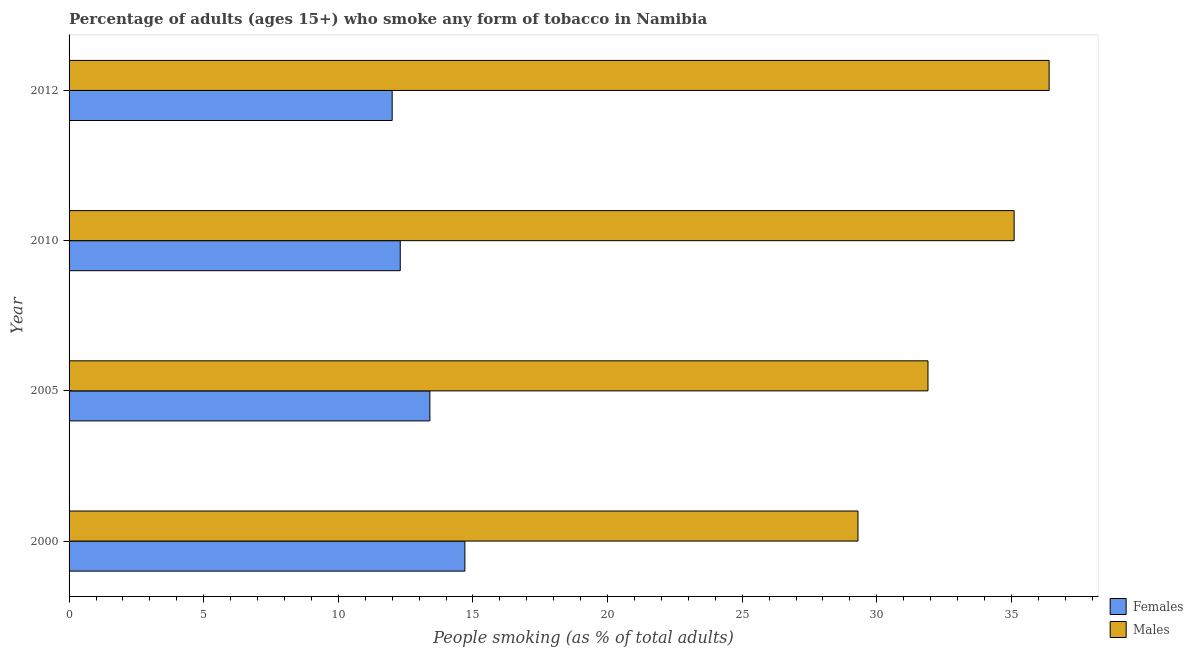Are the number of bars per tick equal to the number of legend labels?
Ensure brevity in your answer.  Yes. Are the number of bars on each tick of the Y-axis equal?
Give a very brief answer. Yes. In how many cases, is the number of bars for a given year not equal to the number of legend labels?
Offer a very short reply. 0. What is the percentage of males who smoke in 2000?
Your response must be concise. 29.3. Across all years, what is the maximum percentage of males who smoke?
Offer a terse response. 36.4. Across all years, what is the minimum percentage of males who smoke?
Your response must be concise. 29.3. In which year was the percentage of females who smoke maximum?
Provide a short and direct response. 2000. In which year was the percentage of males who smoke minimum?
Make the answer very short. 2000. What is the total percentage of females who smoke in the graph?
Your response must be concise. 52.4. What is the difference between the percentage of males who smoke in 2000 and the percentage of females who smoke in 2010?
Provide a short and direct response. 17. What is the average percentage of males who smoke per year?
Offer a very short reply. 33.17. In the year 2010, what is the difference between the percentage of females who smoke and percentage of males who smoke?
Provide a succinct answer. -22.8. In how many years, is the percentage of males who smoke greater than 25 %?
Make the answer very short. 4. What is the ratio of the percentage of females who smoke in 2005 to that in 2010?
Your answer should be compact. 1.09. Is the percentage of males who smoke in 2000 less than that in 2012?
Keep it short and to the point. Yes. What is the difference between the highest and the second highest percentage of males who smoke?
Your response must be concise. 1.3. What is the difference between the highest and the lowest percentage of males who smoke?
Your answer should be very brief. 7.1. In how many years, is the percentage of males who smoke greater than the average percentage of males who smoke taken over all years?
Offer a terse response. 2. What does the 2nd bar from the top in 2000 represents?
Your response must be concise. Females. What does the 2nd bar from the bottom in 2000 represents?
Offer a very short reply. Males. How many bars are there?
Your answer should be very brief. 8. How many years are there in the graph?
Your answer should be very brief. 4. What is the difference between two consecutive major ticks on the X-axis?
Keep it short and to the point. 5. Are the values on the major ticks of X-axis written in scientific E-notation?
Your answer should be compact. No. Does the graph contain any zero values?
Your answer should be very brief. No. Does the graph contain grids?
Give a very brief answer. No. Where does the legend appear in the graph?
Keep it short and to the point. Bottom right. What is the title of the graph?
Offer a terse response. Percentage of adults (ages 15+) who smoke any form of tobacco in Namibia. What is the label or title of the X-axis?
Provide a succinct answer. People smoking (as % of total adults). What is the People smoking (as % of total adults) in Females in 2000?
Make the answer very short. 14.7. What is the People smoking (as % of total adults) in Males in 2000?
Give a very brief answer. 29.3. What is the People smoking (as % of total adults) of Males in 2005?
Offer a very short reply. 31.9. What is the People smoking (as % of total adults) in Males in 2010?
Provide a succinct answer. 35.1. What is the People smoking (as % of total adults) of Females in 2012?
Your response must be concise. 12. What is the People smoking (as % of total adults) in Males in 2012?
Your answer should be very brief. 36.4. Across all years, what is the maximum People smoking (as % of total adults) in Females?
Provide a succinct answer. 14.7. Across all years, what is the maximum People smoking (as % of total adults) in Males?
Your response must be concise. 36.4. Across all years, what is the minimum People smoking (as % of total adults) of Females?
Keep it short and to the point. 12. Across all years, what is the minimum People smoking (as % of total adults) of Males?
Your answer should be compact. 29.3. What is the total People smoking (as % of total adults) in Females in the graph?
Make the answer very short. 52.4. What is the total People smoking (as % of total adults) in Males in the graph?
Make the answer very short. 132.7. What is the difference between the People smoking (as % of total adults) of Females in 2000 and that in 2005?
Keep it short and to the point. 1.3. What is the difference between the People smoking (as % of total adults) in Males in 2000 and that in 2005?
Keep it short and to the point. -2.6. What is the difference between the People smoking (as % of total adults) of Males in 2000 and that in 2010?
Your answer should be compact. -5.8. What is the difference between the People smoking (as % of total adults) in Females in 2005 and that in 2012?
Make the answer very short. 1.4. What is the difference between the People smoking (as % of total adults) in Females in 2000 and the People smoking (as % of total adults) in Males in 2005?
Keep it short and to the point. -17.2. What is the difference between the People smoking (as % of total adults) of Females in 2000 and the People smoking (as % of total adults) of Males in 2010?
Give a very brief answer. -20.4. What is the difference between the People smoking (as % of total adults) of Females in 2000 and the People smoking (as % of total adults) of Males in 2012?
Your answer should be compact. -21.7. What is the difference between the People smoking (as % of total adults) of Females in 2005 and the People smoking (as % of total adults) of Males in 2010?
Ensure brevity in your answer.  -21.7. What is the difference between the People smoking (as % of total adults) of Females in 2010 and the People smoking (as % of total adults) of Males in 2012?
Offer a very short reply. -24.1. What is the average People smoking (as % of total adults) in Females per year?
Your response must be concise. 13.1. What is the average People smoking (as % of total adults) of Males per year?
Provide a succinct answer. 33.17. In the year 2000, what is the difference between the People smoking (as % of total adults) of Females and People smoking (as % of total adults) of Males?
Your answer should be compact. -14.6. In the year 2005, what is the difference between the People smoking (as % of total adults) in Females and People smoking (as % of total adults) in Males?
Provide a succinct answer. -18.5. In the year 2010, what is the difference between the People smoking (as % of total adults) in Females and People smoking (as % of total adults) in Males?
Your response must be concise. -22.8. In the year 2012, what is the difference between the People smoking (as % of total adults) in Females and People smoking (as % of total adults) in Males?
Provide a short and direct response. -24.4. What is the ratio of the People smoking (as % of total adults) of Females in 2000 to that in 2005?
Provide a short and direct response. 1.1. What is the ratio of the People smoking (as % of total adults) in Males in 2000 to that in 2005?
Provide a short and direct response. 0.92. What is the ratio of the People smoking (as % of total adults) in Females in 2000 to that in 2010?
Make the answer very short. 1.2. What is the ratio of the People smoking (as % of total adults) in Males in 2000 to that in 2010?
Give a very brief answer. 0.83. What is the ratio of the People smoking (as % of total adults) in Females in 2000 to that in 2012?
Provide a short and direct response. 1.23. What is the ratio of the People smoking (as % of total adults) of Males in 2000 to that in 2012?
Your answer should be compact. 0.8. What is the ratio of the People smoking (as % of total adults) in Females in 2005 to that in 2010?
Your answer should be compact. 1.09. What is the ratio of the People smoking (as % of total adults) of Males in 2005 to that in 2010?
Provide a succinct answer. 0.91. What is the ratio of the People smoking (as % of total adults) of Females in 2005 to that in 2012?
Your response must be concise. 1.12. What is the ratio of the People smoking (as % of total adults) of Males in 2005 to that in 2012?
Your response must be concise. 0.88. What is the ratio of the People smoking (as % of total adults) in Females in 2010 to that in 2012?
Your answer should be very brief. 1.02. What is the ratio of the People smoking (as % of total adults) of Males in 2010 to that in 2012?
Your answer should be compact. 0.96. What is the difference between the highest and the second highest People smoking (as % of total adults) in Males?
Offer a very short reply. 1.3. 